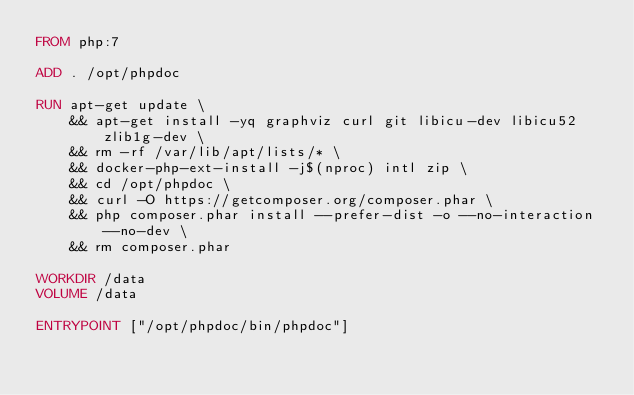<code> <loc_0><loc_0><loc_500><loc_500><_Dockerfile_>FROM php:7

ADD . /opt/phpdoc

RUN apt-get update \
    && apt-get install -yq graphviz curl git libicu-dev libicu52 zlib1g-dev \
    && rm -rf /var/lib/apt/lists/* \
    && docker-php-ext-install -j$(nproc) intl zip \
    && cd /opt/phpdoc \
    && curl -O https://getcomposer.org/composer.phar \
    && php composer.phar install --prefer-dist -o --no-interaction --no-dev \
    && rm composer.phar

WORKDIR /data
VOLUME /data

ENTRYPOINT ["/opt/phpdoc/bin/phpdoc"]
</code> 